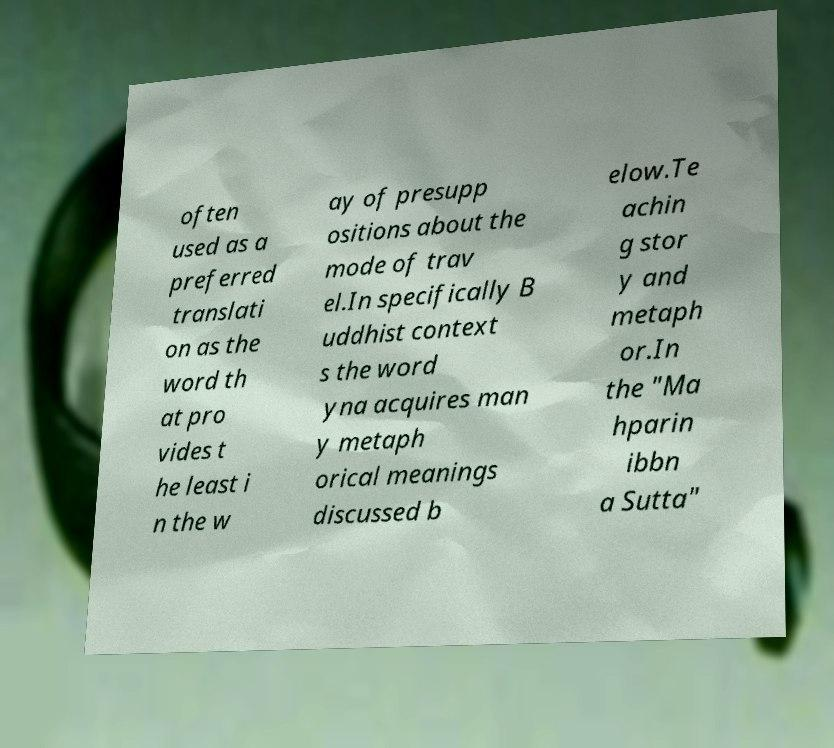Could you extract and type out the text from this image? often used as a preferred translati on as the word th at pro vides t he least i n the w ay of presupp ositions about the mode of trav el.In specifically B uddhist context s the word yna acquires man y metaph orical meanings discussed b elow.Te achin g stor y and metaph or.In the "Ma hparin ibbn a Sutta" 